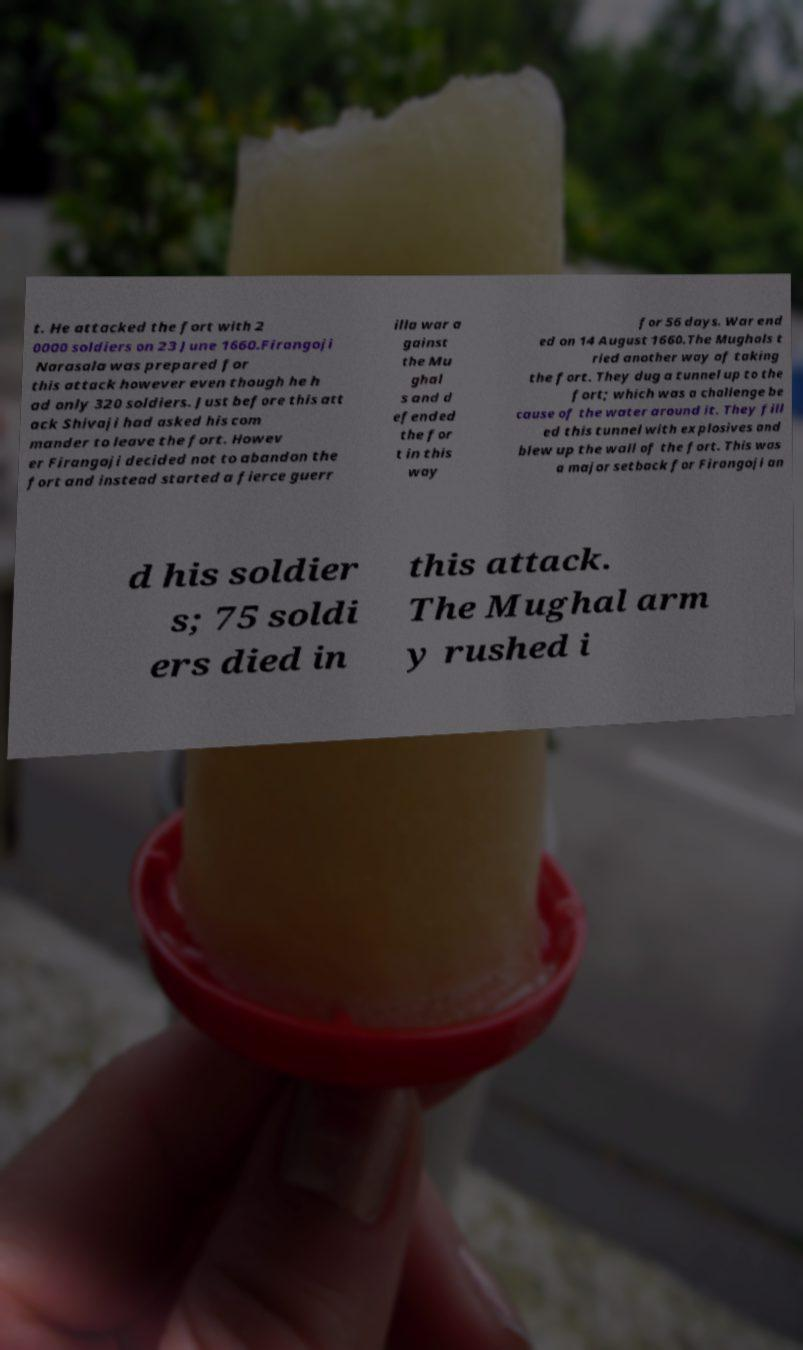There's text embedded in this image that I need extracted. Can you transcribe it verbatim? t. He attacked the fort with 2 0000 soldiers on 23 June 1660.Firangoji Narasala was prepared for this attack however even though he h ad only 320 soldiers. Just before this att ack Shivaji had asked his com mander to leave the fort. Howev er Firangoji decided not to abandon the fort and instead started a fierce guerr illa war a gainst the Mu ghal s and d efended the for t in this way for 56 days. War end ed on 14 August 1660.The Mughals t ried another way of taking the fort. They dug a tunnel up to the fort; which was a challenge be cause of the water around it. They fill ed this tunnel with explosives and blew up the wall of the fort. This was a major setback for Firangoji an d his soldier s; 75 soldi ers died in this attack. The Mughal arm y rushed i 